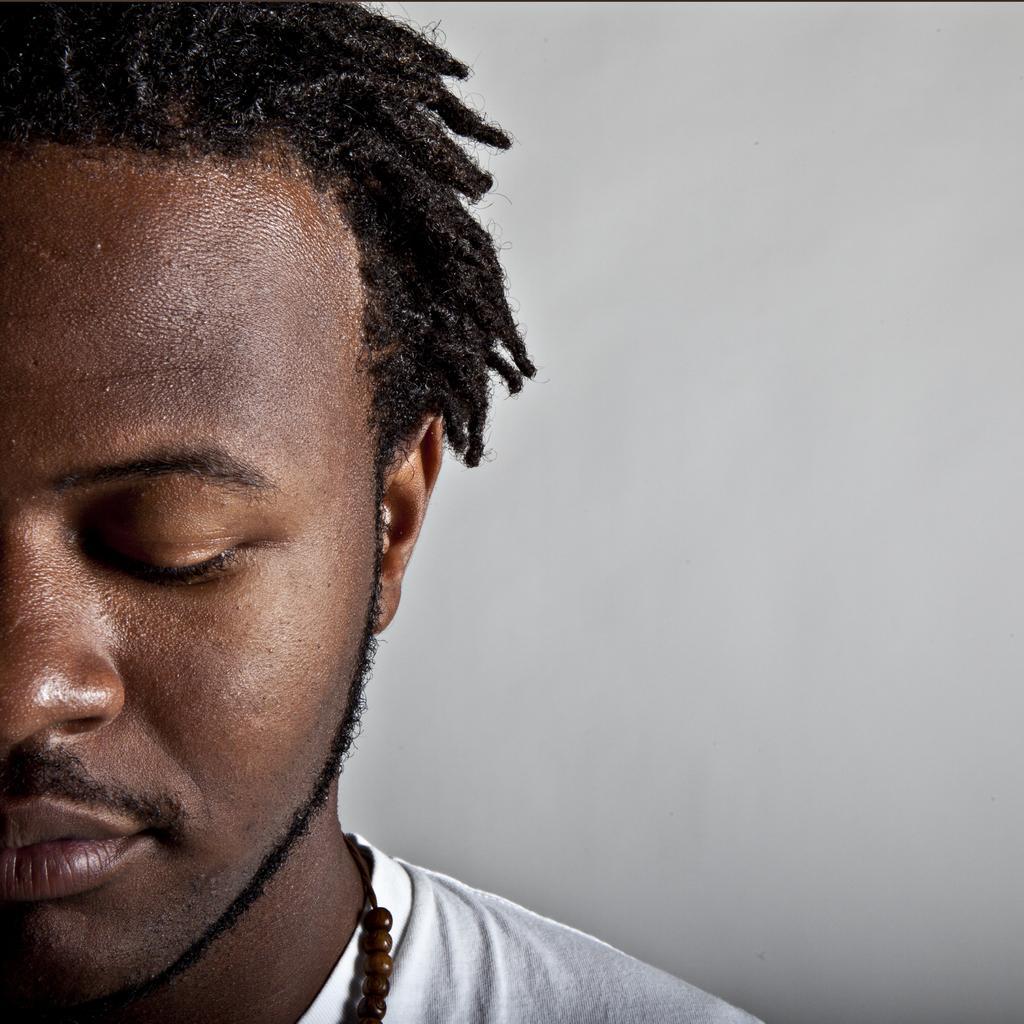Describe this image in one or two sentences. In this picture in the front there is a man. 